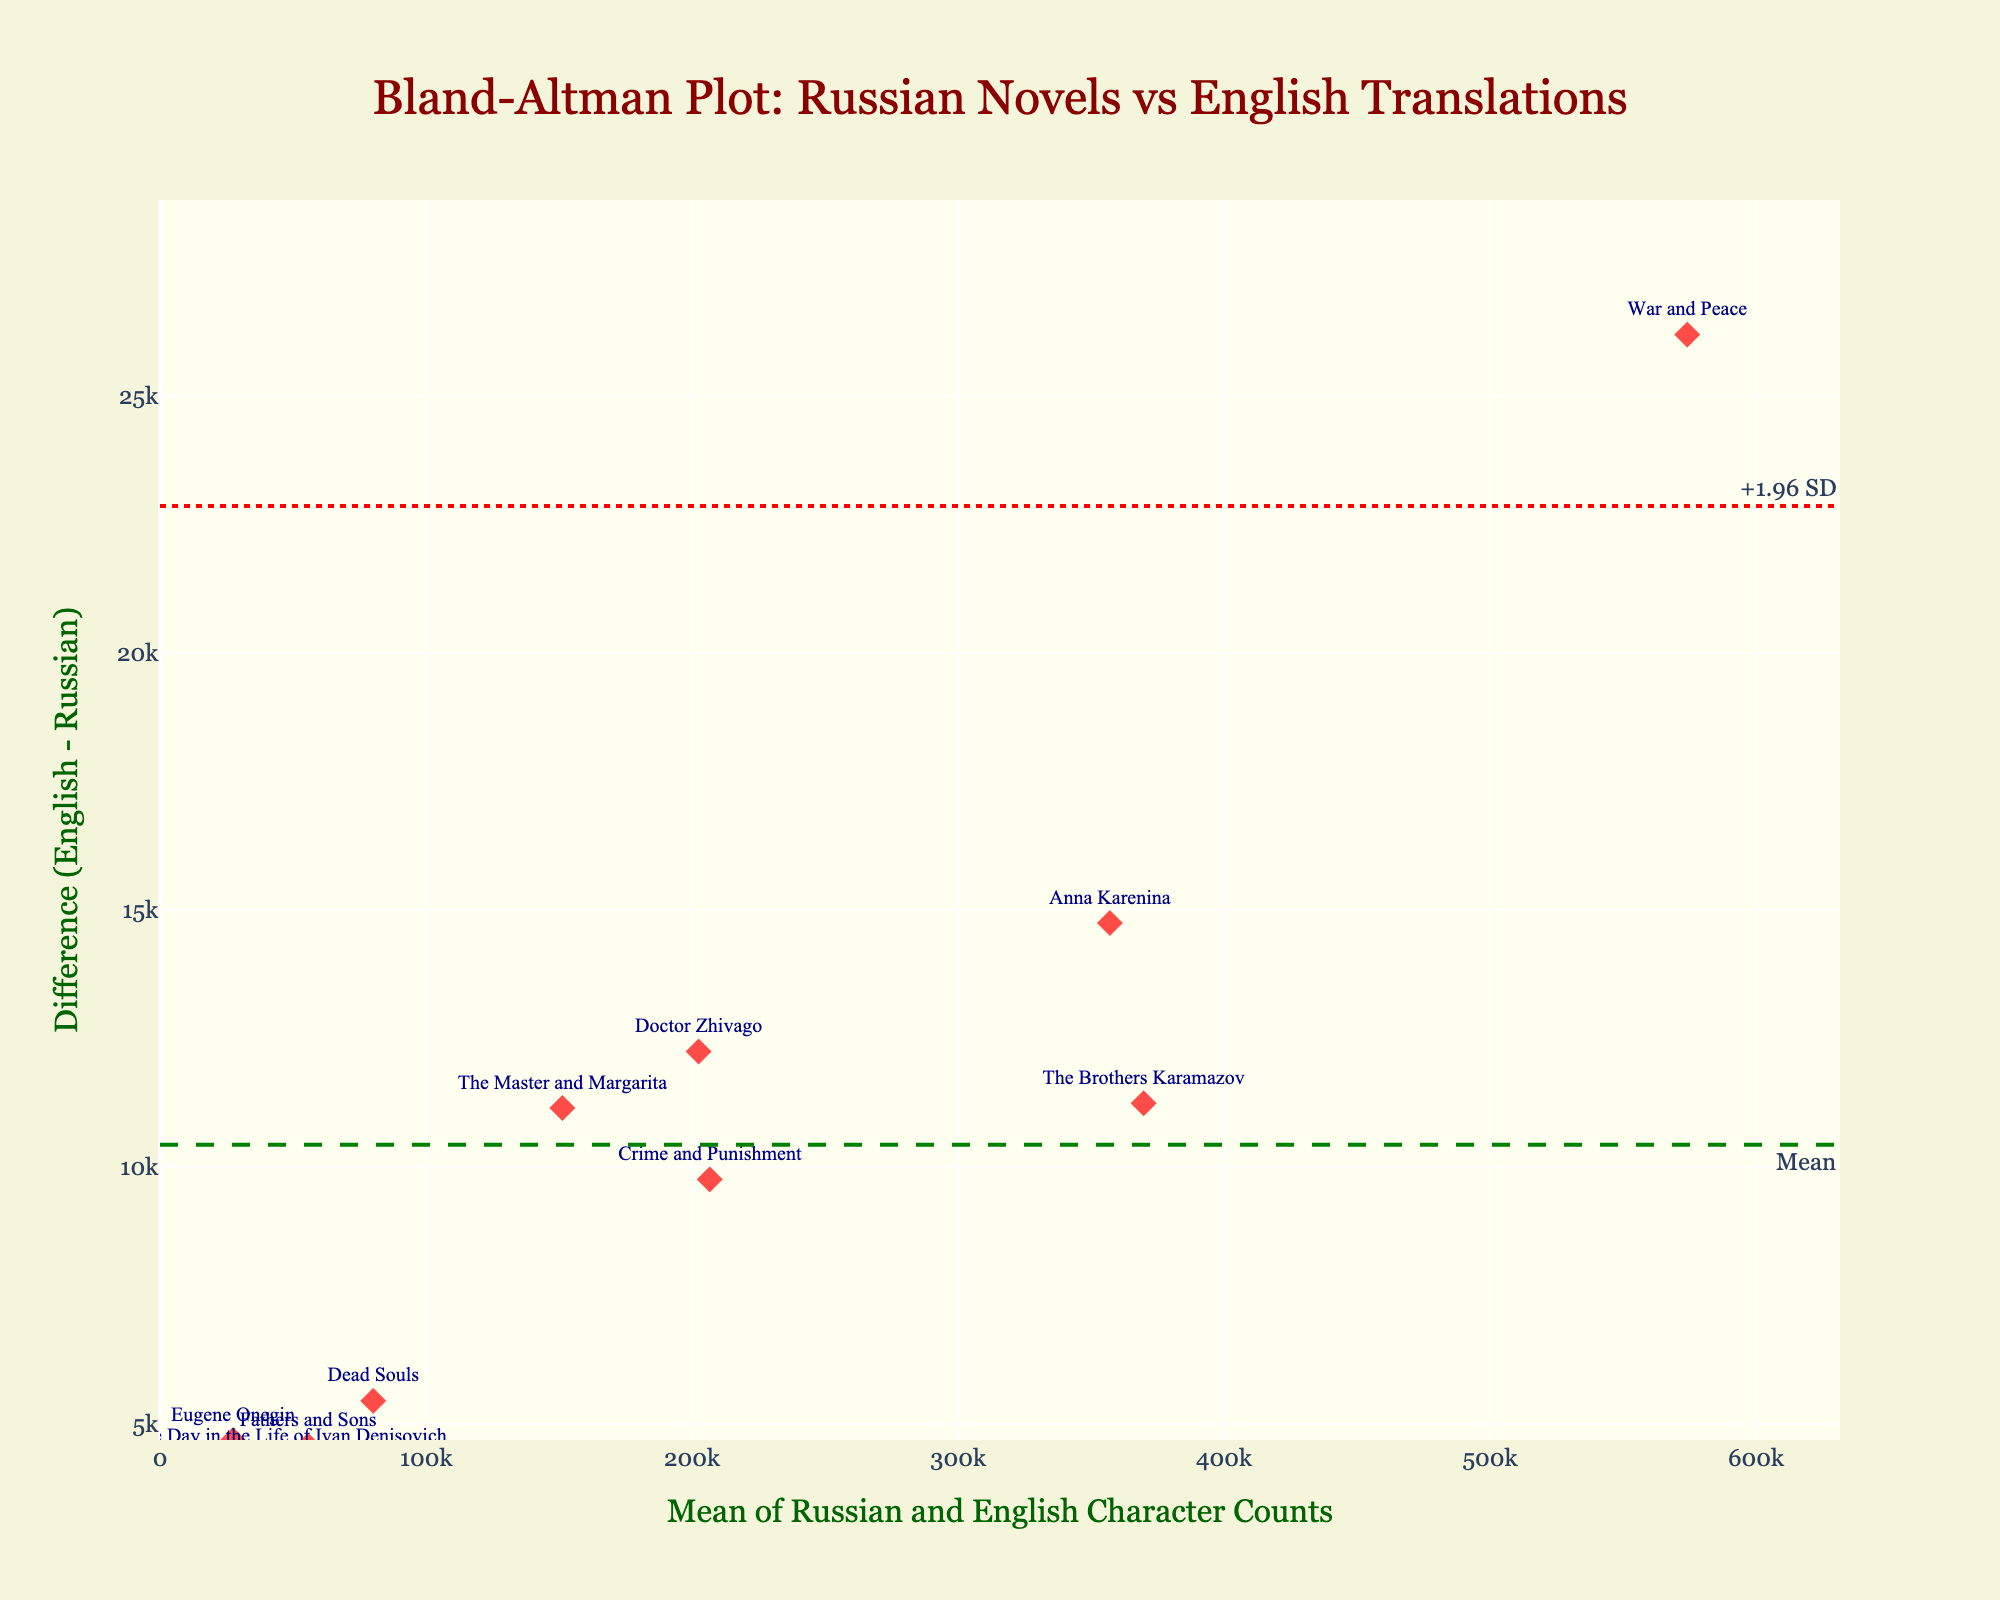What's the title of the plot? The title is typically displayed at the top center of the plot. In this case, it reads "Bland-Altman Plot: Russian Novels vs English Translations".
Answer: Bland-Altman Plot: Russian Novels vs English Translations What are the labels of the axes? The x-axis title is located at the bottom center of the plot, and the y-axis title is centered along the left vertical axis. The x-axis title is "Mean of Russian and English Character Counts," and the y-axis title is "Difference (English - Russian)".
Answer: Mean of Russian and English Character Counts, Difference (English - Russian) How many novels are displayed in the plot? The number of novels can be counted by counting the data points labeled with their respective titles. According to the provided data set, there are 10 novels.
Answer: 10 Which novel shows the largest difference between the Russian and English character counts? Comparing the difference values for each novel, the one with the most significant absolute difference is "War and Peace" with a difference of -26194.
Answer: War and Peace What is the color of the data points in the plot? The color of the data points is visible as a distinguishing feature. In this plot, the data points are shown in a shade of red.
Answer: Red What do the dashed and dotted lines represent in the plot? The dashed line represents the mean difference between the character counts, while the dotted lines indicate the limits of agreement, typically ±1.96 standard deviations from the mean difference.
Answer: Mean difference, Limits of agreement What's the mean difference between the Russian and English character counts? The mean difference is marked by a horizontal dashed line and is annotated at the right end of the line.
Answer: -10266.4 Are most translations longer or shorter than their original Russian novels? To determine this, look at the differences between English and Russian character counts. Most points being below the zero line indicate that most translations are longer than their originals as the difference is (English - Russian).
Answer: Longer Which novel has the smallest difference in character counts? Upon examining the differences, the novel with the smallest absolute difference is "One Day in the Life of Ivan Denisovich," with a difference of -4264.
Answer: One Day in the Life of Ivan Denisovich What is the range of the mean axis in the plot? The range of the mean axis (x-axis) can be seen by observing its minimum and maximum values. The minimum starts at 0, and it extends to roughly 630,000.
Answer: 0 to 630,000 